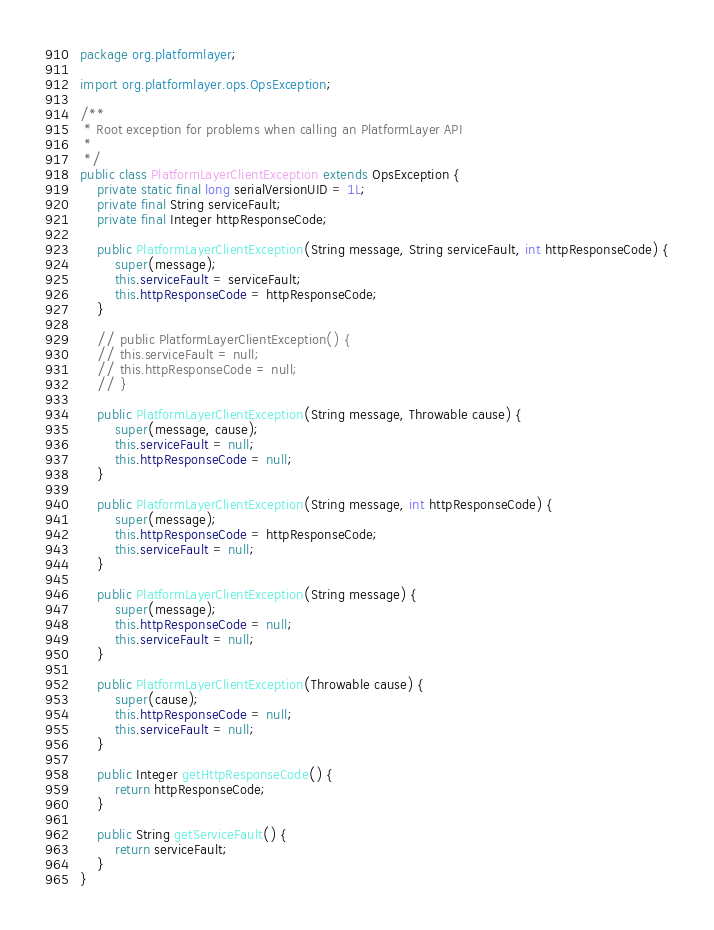<code> <loc_0><loc_0><loc_500><loc_500><_Java_>package org.platformlayer;

import org.platformlayer.ops.OpsException;

/**
 * Root exception for problems when calling an PlatformLayer API
 * 
 */
public class PlatformLayerClientException extends OpsException {
	private static final long serialVersionUID = 1L;
	private final String serviceFault;
	private final Integer httpResponseCode;

	public PlatformLayerClientException(String message, String serviceFault, int httpResponseCode) {
		super(message);
		this.serviceFault = serviceFault;
		this.httpResponseCode = httpResponseCode;
	}

	// public PlatformLayerClientException() {
	// this.serviceFault = null;
	// this.httpResponseCode = null;
	// }

	public PlatformLayerClientException(String message, Throwable cause) {
		super(message, cause);
		this.serviceFault = null;
		this.httpResponseCode = null;
	}

	public PlatformLayerClientException(String message, int httpResponseCode) {
		super(message);
		this.httpResponseCode = httpResponseCode;
		this.serviceFault = null;
	}

	public PlatformLayerClientException(String message) {
		super(message);
		this.httpResponseCode = null;
		this.serviceFault = null;
	}

	public PlatformLayerClientException(Throwable cause) {
		super(cause);
		this.httpResponseCode = null;
		this.serviceFault = null;
	}

	public Integer getHttpResponseCode() {
		return httpResponseCode;
	}

	public String getServiceFault() {
		return serviceFault;
	}
}
</code> 